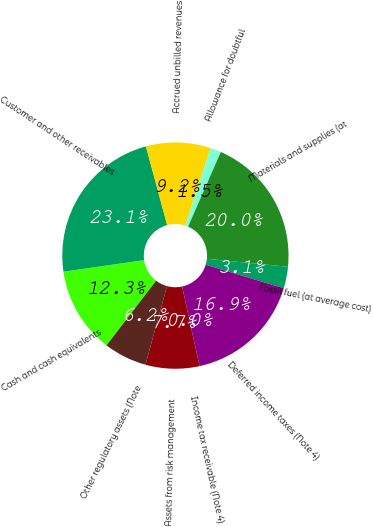Convert chart. <chart><loc_0><loc_0><loc_500><loc_500><pie_chart><fcel>Cash and cash equivalents<fcel>Customer and other receivables<fcel>Accrued unbilled revenues<fcel>Allowance for doubtful<fcel>Materials and supplies (at<fcel>Fossil fuel (at average cost)<fcel>Deferred income taxes (Note 4)<fcel>Income tax receivable (Note 4)<fcel>Assets from risk management<fcel>Other regulatory assets (Note<nl><fcel>12.31%<fcel>23.07%<fcel>9.23%<fcel>1.54%<fcel>20.0%<fcel>3.08%<fcel>16.92%<fcel>0.0%<fcel>7.69%<fcel>6.15%<nl></chart> 